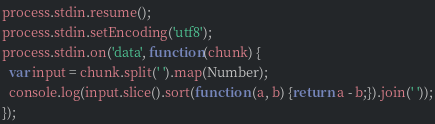<code> <loc_0><loc_0><loc_500><loc_500><_JavaScript_>process.stdin.resume();
process.stdin.setEncoding('utf8');
process.stdin.on('data', function(chunk) {
  var input = chunk.split(' ').map(Number);
  console.log(input.slice().sort(function (a, b) {return a - b;}).join(' '));
});</code> 